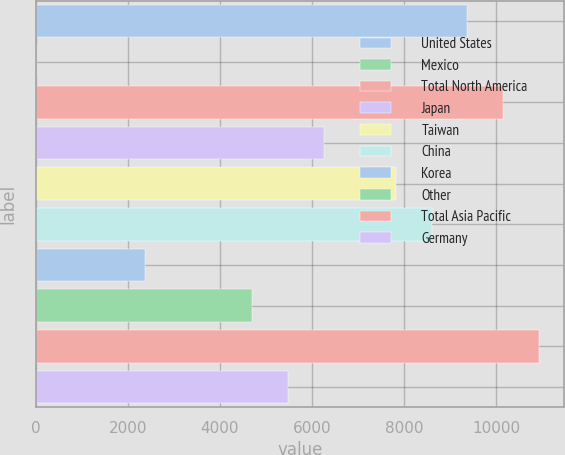Convert chart. <chart><loc_0><loc_0><loc_500><loc_500><bar_chart><fcel>United States<fcel>Mexico<fcel>Total North America<fcel>Japan<fcel>Taiwan<fcel>China<fcel>Korea<fcel>Other<fcel>Total Asia Pacific<fcel>Germany<nl><fcel>9378.2<fcel>23<fcel>10157.8<fcel>6259.8<fcel>7819<fcel>8598.6<fcel>2361.8<fcel>4700.6<fcel>10937.4<fcel>5480.2<nl></chart> 